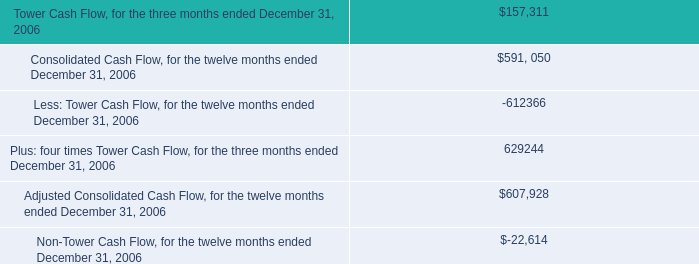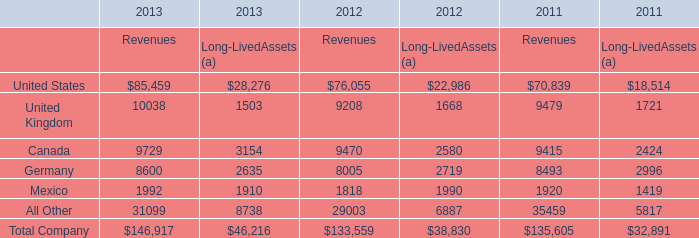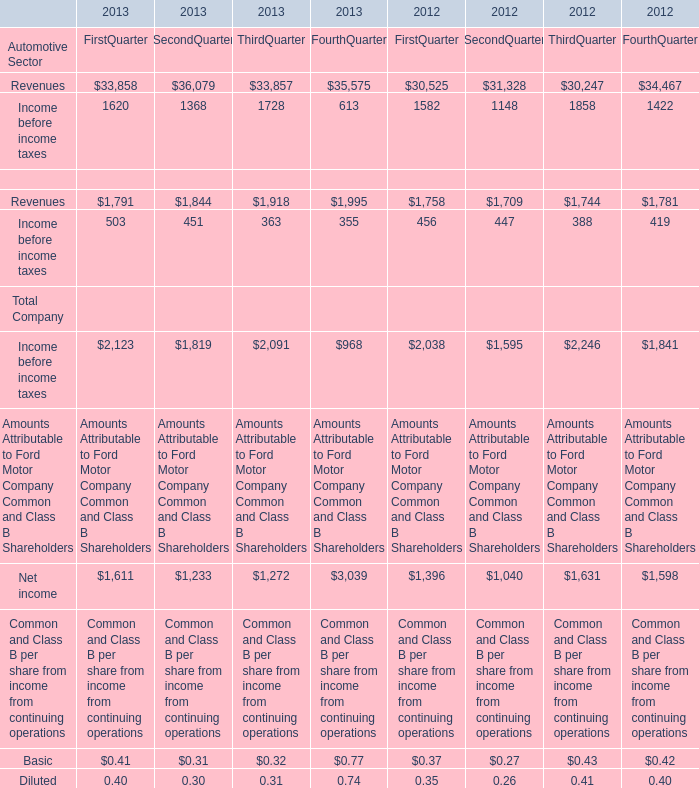What's the sum of all Revenues of Automotive Sector that are positive in 2013? 
Computations: (((33858 + 36079) + 33857) + 35575)
Answer: 139369.0. 